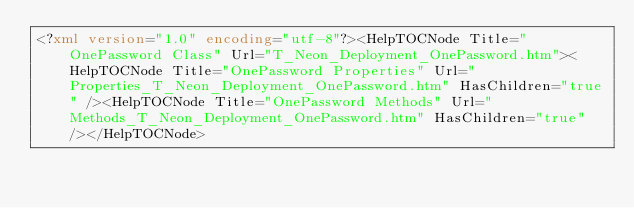Convert code to text. <code><loc_0><loc_0><loc_500><loc_500><_XML_><?xml version="1.0" encoding="utf-8"?><HelpTOCNode Title="OnePassword Class" Url="T_Neon_Deployment_OnePassword.htm"><HelpTOCNode Title="OnePassword Properties" Url="Properties_T_Neon_Deployment_OnePassword.htm" HasChildren="true" /><HelpTOCNode Title="OnePassword Methods" Url="Methods_T_Neon_Deployment_OnePassword.htm" HasChildren="true" /></HelpTOCNode></code> 